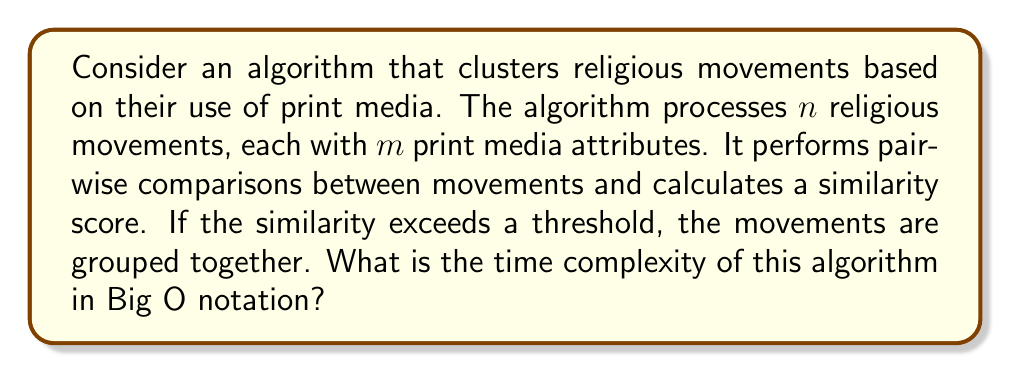Solve this math problem. To analyze the time complexity of this algorithm, let's break it down step-by-step:

1. The algorithm processes $n$ religious movements.

2. For each movement, it compares $m$ print media attributes.

3. To perform clustering, the algorithm needs to compare each movement with every other movement. This results in $\binom{n}{2} = \frac{n(n-1)}{2}$ comparisons.

4. For each comparison, the algorithm calculates a similarity score based on $m$ attributes.

5. The calculation of similarity for $m$ attributes takes $O(m)$ time.

6. Therefore, the total time complexity is:

   $$O(\binom{n}{2} \cdot m) = O(\frac{n(n-1)}{2} \cdot m)$$

7. Simplifying this expression:

   $$O(\frac{n^2m - nm}{2})$$

8. In Big O notation, we focus on the highest order term and drop constant factors:

   $$O(n^2m)$$

This quadratic time complexity in terms of $n$ is typical for clustering algorithms that perform pairwise comparisons.
Answer: $O(n^2m)$ 